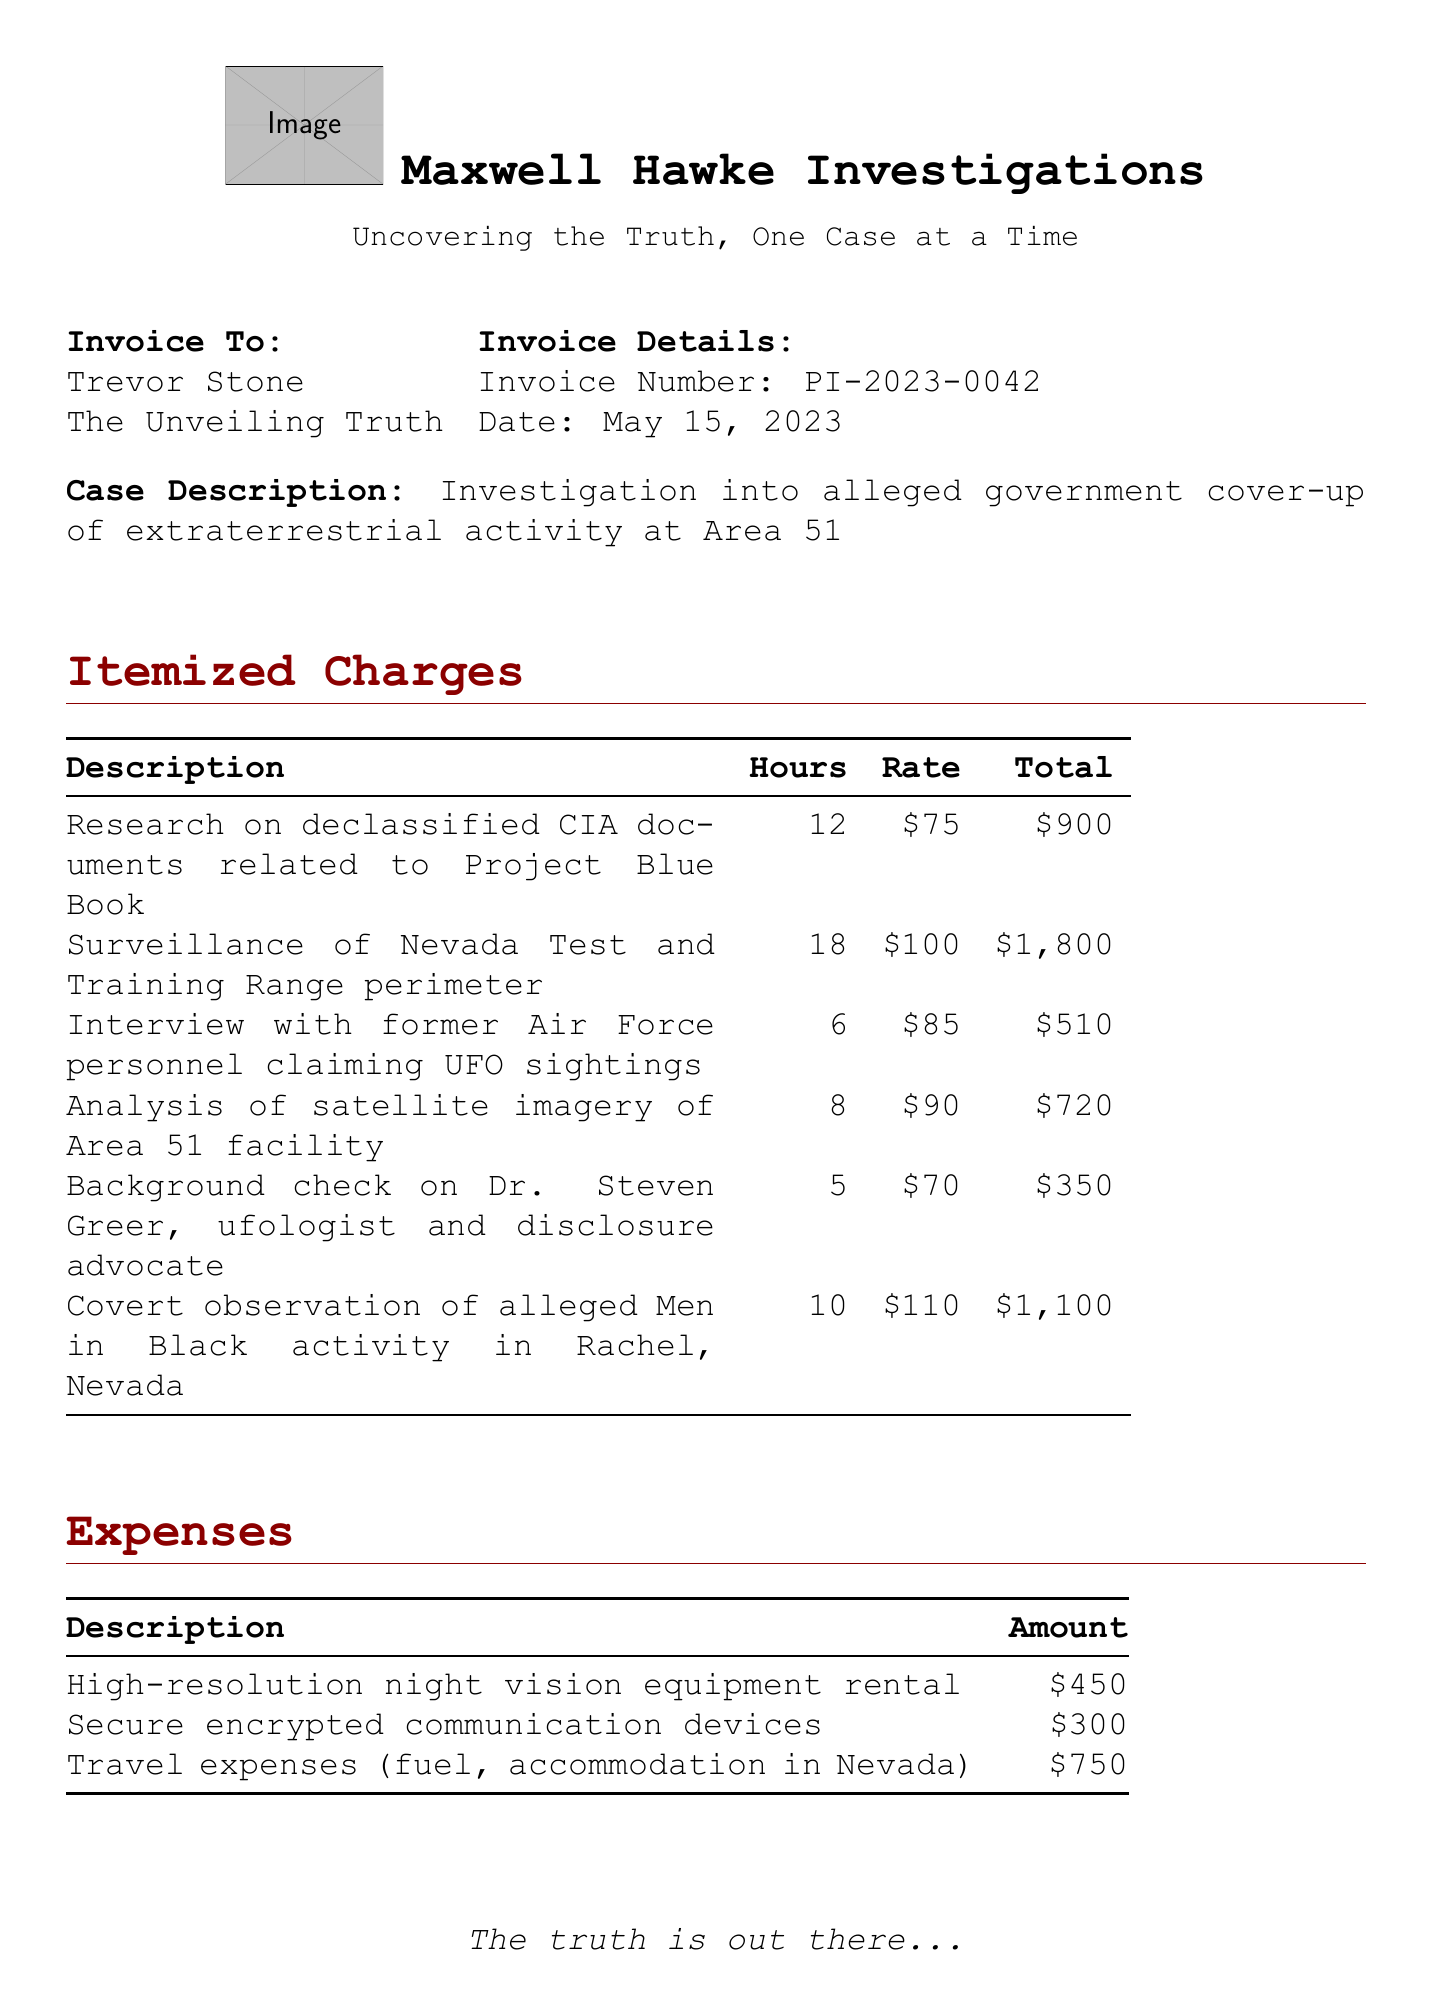What is the invoice number? The invoice number is specified near the top of the document.
Answer: PI-2023-0042 Who is the investigator? The investigator's name is listed in the document header.
Answer: Maxwell Hawke What was the total due amount? The total due amount is calculated at the bottom of the invoice.
Answer: 7430.40 How many hours were spent on surveillance? The document itemizes hours spent on each activity, including surveillance.
Answer: 18 What is the rate for analyzing satellite imagery? The rate is provided alongside the total for each itemized charge.
Answer: 90 What expense was incurred for communications? The expenses section lists various costs, including those for secure communications.
Answer: 300 What is the payment term specified in the invoice? The payment terms are mentioned towards the end of the document.
Answer: Due within 30 days Which technology-related investigation is recommended for follow-up? The notes section provides recommendations based on the findings.
Answer: Dulce Base, New Mexico 